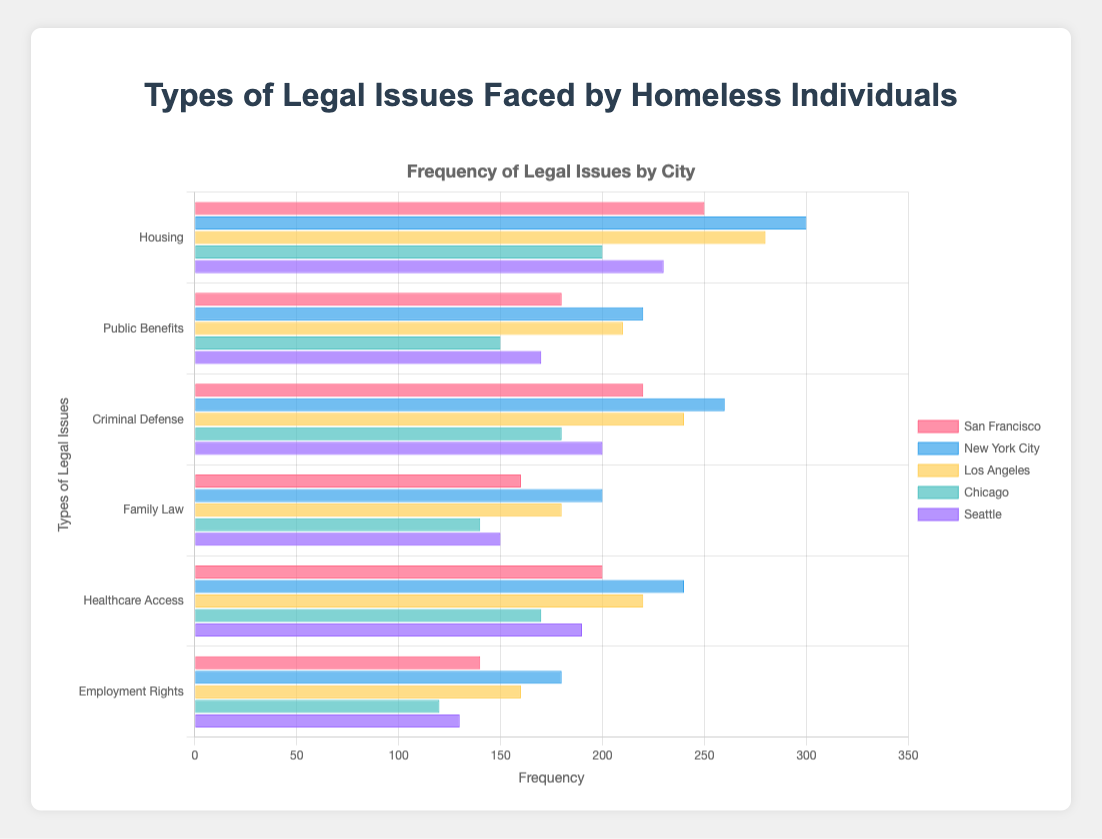What city's homeless individuals face the most legal issues regarding "Housing"? Look at the "Housing" category and compare the height of the bars for each city. New York City's bar is the tallest in this category.
Answer: New York City Which type of legal issue is most frequent in San Francisco? Examine the lengths of the bars specific to San Francisco across all legal issues. "Housing" has the longest bar for San Francisco.
Answer: Housing Among all cities, which city has the lowest frequency for "Employment Rights"? Look at the "Employment Rights" category and compare the lengths of all bars. Chicago's bar is the shortest.
Answer: Chicago What is the difference in frequency of "Criminal Defense" issues between New York City and Chicago? Identify the "Criminal Defense" category and locate the bars for New York City and Chicago. The difference is 260 (New York City) - 180 (Chicago) = 80.
Answer: 80 What is the average frequency of "Healthcare Access" issues across all cities? Sum the frequencies of "Healthcare Access" issues for all cities and then divide by the number of cities. The sum is 200 (SF) + 240 (NYC) + 220 (LA) + 170 (Chicago) + 190 (Seattle) = 1020. The average is 1020 / 5 = 204.
Answer: 204 Which city has a higher frequency of "Public Benefits" issues: Los Angeles or Seattle? Compare the lengths of the bars for "Public Benefits" for both Los Angeles and Seattle. Los Angeles's bar is longer.
Answer: Los Angeles In which type of legal issue does Seattle have the highest frequency compared to the other categories within the same city? Compare the lengths of all bars for Seattle. The "Housing" bar is the longest.
Answer: Housing What is the total frequency of "Family Law" issues across all cities? Add up the frequencies of "Family Law" issues for all cities. The sum is 160 (SF) + 200 (NYC) + 180 (LA) + 140 (Chicago) + 150 (Seattle) = 830.
Answer: 830 Which city has the second highest frequency for "Healthcare Access"? Identify the "Healthcare Access" category and rank the cities by the length of the bars. San Francisco has the second highest frequency after New York City.
Answer: San Francisco If we sum up the frequencies of "Public Benefits" and "Employment Rights" for Chicago, what is the total? Add the frequencies of "Public Benefits" and "Employment Rights" for Chicago. The sum is 150 (Public Benefits) + 120 (Employment Rights) = 270.
Answer: 270 